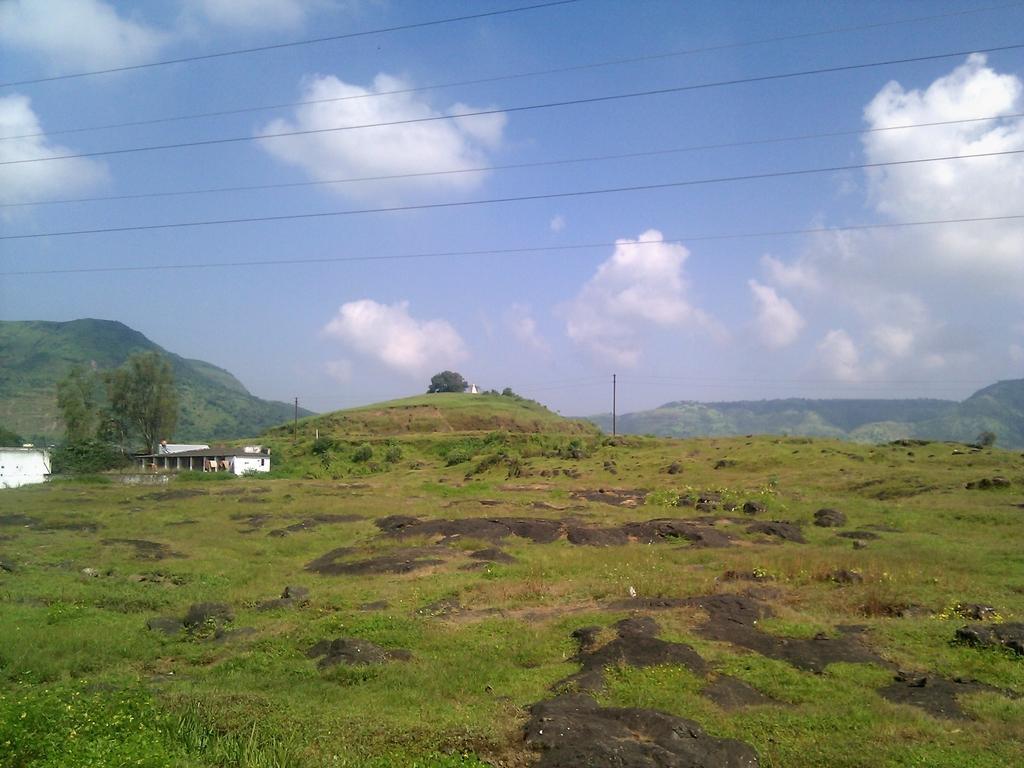Please provide a concise description of this image. In this picture there is a building on the left side of the image. At the back there are mountains, trees and poles. At the top there is sky and there are clouds, wires. At the bottom there is grass. 